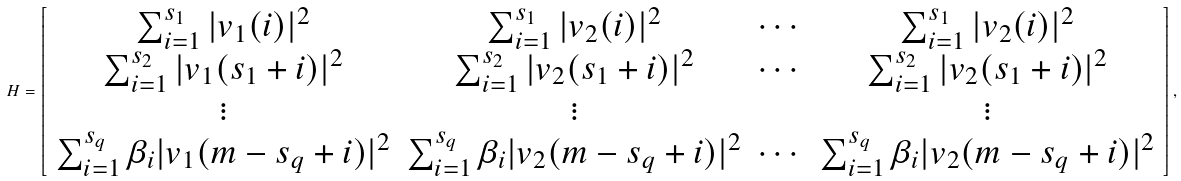Convert formula to latex. <formula><loc_0><loc_0><loc_500><loc_500>H = \left [ \begin{array} { c c c c } \sum _ { i = 1 } ^ { s _ { 1 } } | v _ { 1 } ( i ) | ^ { 2 } & \sum _ { i = 1 } ^ { s _ { 1 } } | v _ { 2 } ( i ) | ^ { 2 } & \cdots & \sum _ { i = 1 } ^ { s _ { 1 } } | v _ { 2 } ( i ) | ^ { 2 } \\ \sum _ { i = 1 } ^ { s _ { 2 } } | v _ { 1 } ( s _ { 1 } + i ) | ^ { 2 } & \sum _ { i = 1 } ^ { s _ { 2 } } | v _ { 2 } ( s _ { 1 } + i ) | ^ { 2 } & \cdots & \sum _ { i = 1 } ^ { s _ { 2 } } | v _ { 2 } ( s _ { 1 } + i ) | ^ { 2 } \\ \vdots & \vdots & & \vdots \\ \sum _ { i = 1 } ^ { s _ { q } } \beta _ { i } | v _ { 1 } ( m - s _ { q } + i ) | ^ { 2 } & \sum _ { i = 1 } ^ { s _ { q } } \beta _ { i } | v _ { 2 } ( m - s _ { q } + i ) | ^ { 2 } & \cdots & \sum _ { i = 1 } ^ { s _ { q } } \beta _ { i } | v _ { 2 } ( m - s _ { q } + i ) | ^ { 2 } \\ \end{array} \right ] ,</formula> 